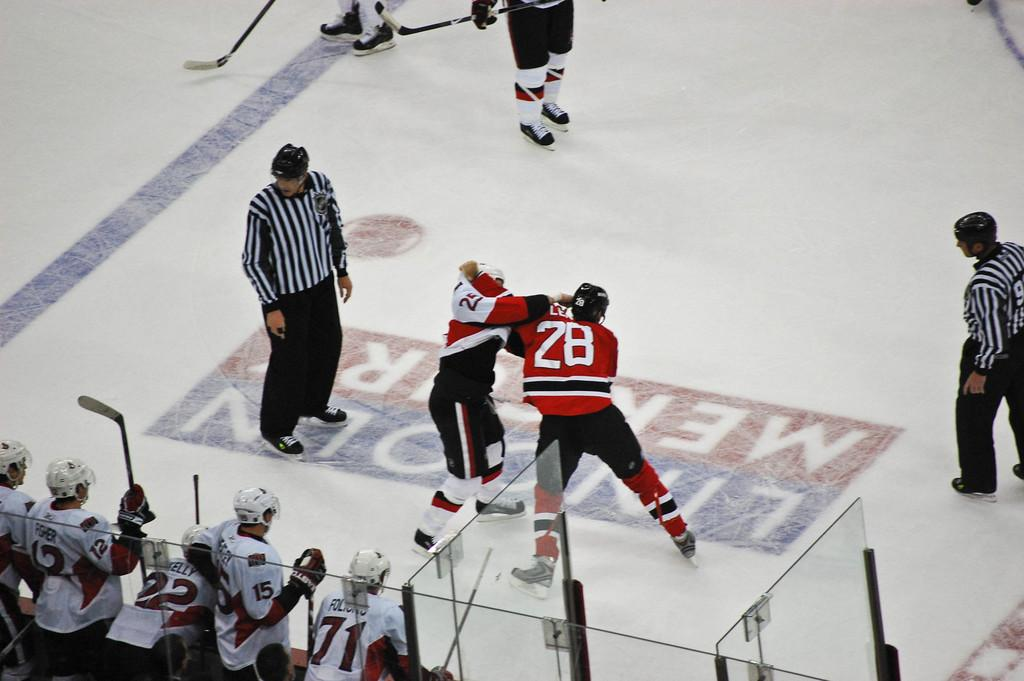What are the two persons in the image doing? Two persons are fighting in the image. Are there any other people present in the image? Yes, there are other people standing in the image. What type of object can be seen in the image that is made of glass? There is a glass object in the image. What weapon is being used in the fight? There is a bat in the image, which might be used as a weapon. What is the interest rate of the loan that the person in the image is discussing? There is no mention of a loan or interest rate in the image; the main focus is on the fight between two persons. 